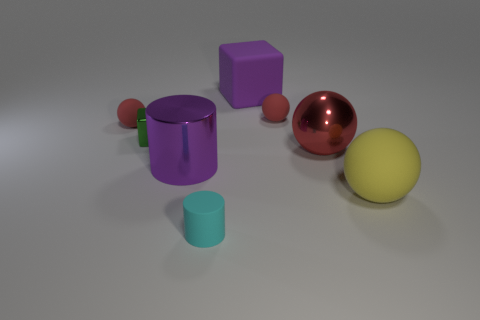Subtract all brown cubes. How many red spheres are left? 3 Subtract 1 spheres. How many spheres are left? 3 Add 2 small yellow rubber things. How many objects exist? 10 Subtract all cylinders. How many objects are left? 6 Add 6 metallic things. How many metallic things exist? 9 Subtract 0 blue cylinders. How many objects are left? 8 Subtract all big red balls. Subtract all small red rubber things. How many objects are left? 5 Add 6 large objects. How many large objects are left? 10 